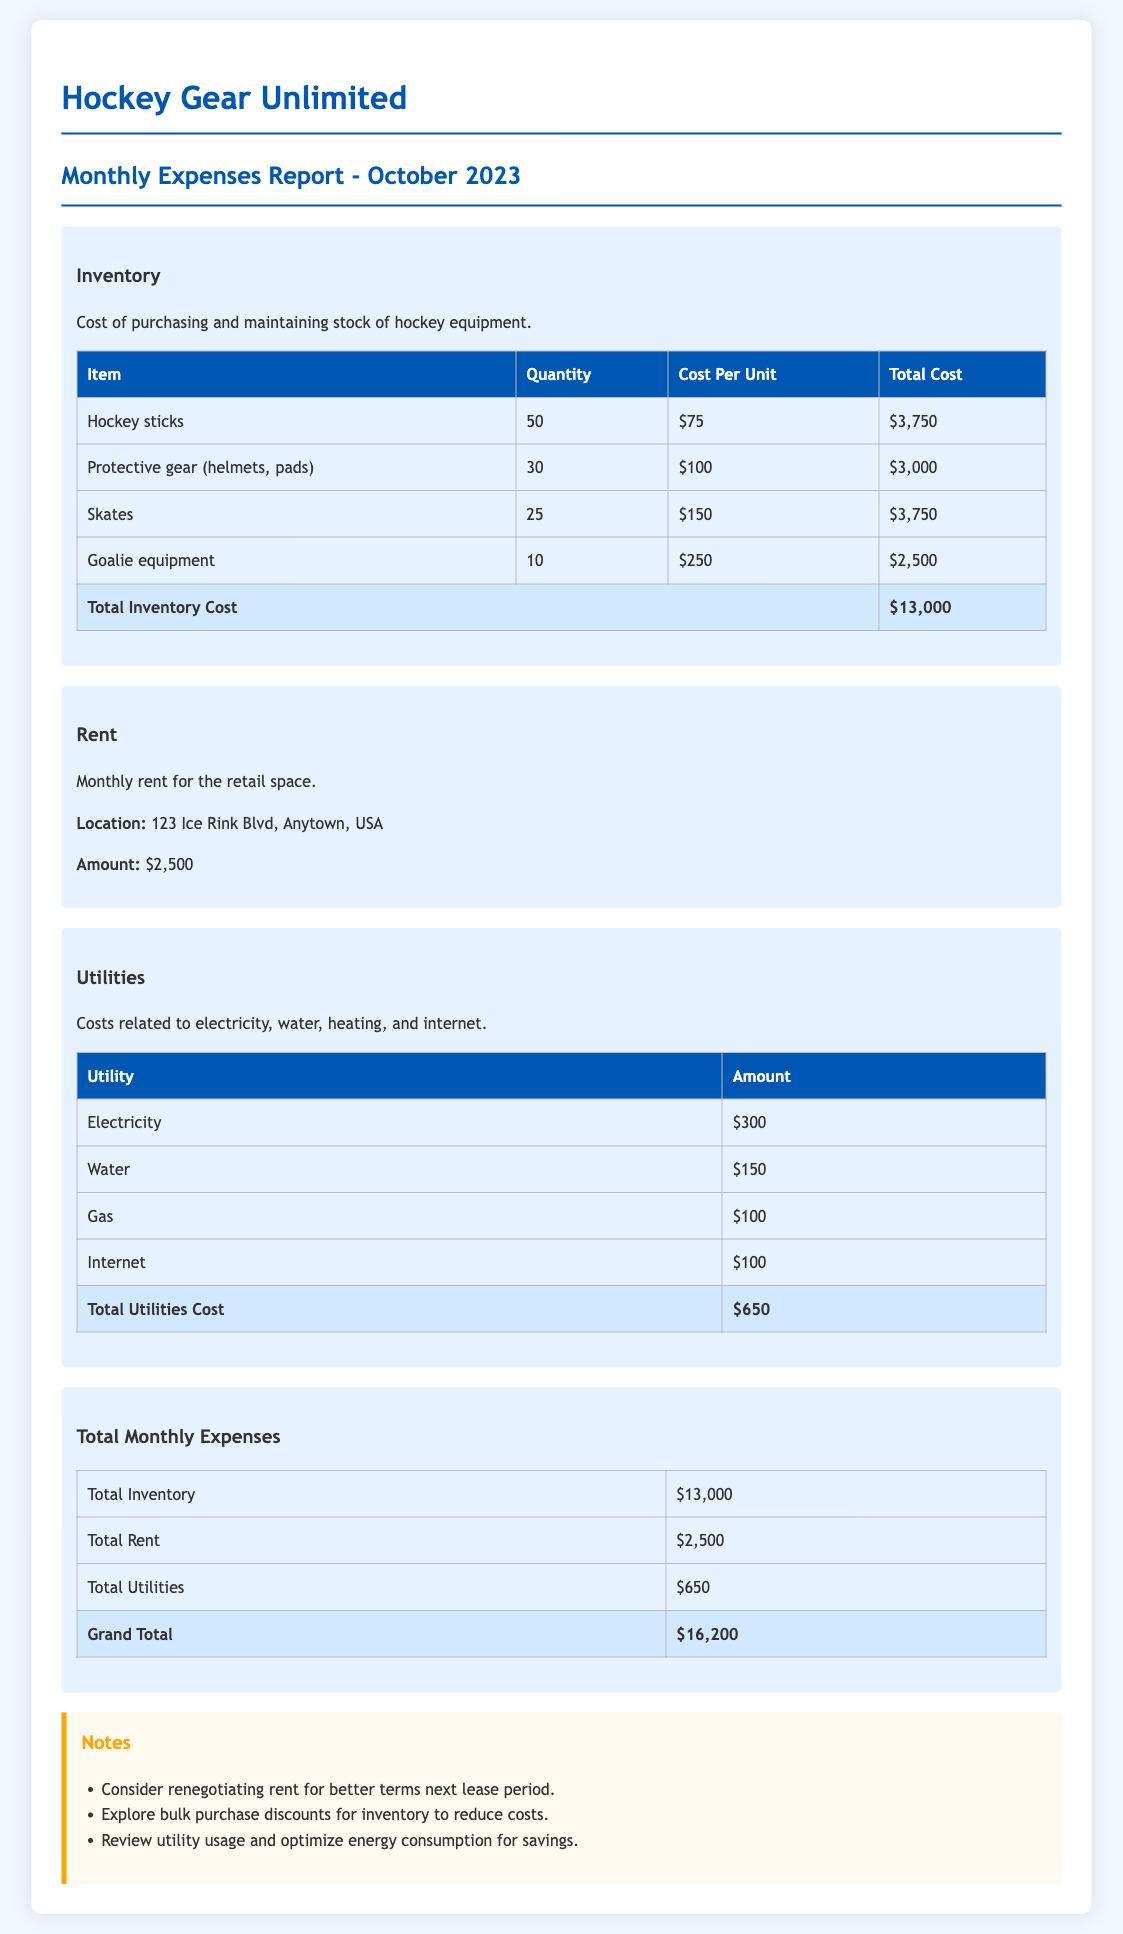What is the total cost of hockey sticks? The total cost of hockey sticks is listed in the inventory section as $3,750.
Answer: $3,750 How much is the monthly rent? The monthly rent amount for the retail space is stated directly in the rent section as $2,500.
Answer: $2,500 What is the total utilities cost? The total cost of utilities is summarized at the end of the utilities section as $650.
Answer: $650 How many pieces of protective gear were purchased? The quantity of protective gear is provided in the inventory table as 30.
Answer: 30 What is the grand total for monthly expenses? The grand total is calculated at the end of the monthly expenses section as $16,200.
Answer: $16,200 Which utility has the highest cost? The highest utility cost is electricity, listed at $300.
Answer: Electricity What recommendation is given regarding rent? The document suggests to consider renegotiating rent for better terms next lease period.
Answer: Renegotiating rent How much did the goalie equipment cost? The cost for goalie equipment is recorded in the inventory section as $2,500.
Answer: $2,500 Which utility cost is the lowest? The lowest utility cost is gas, with an amount of $100.
Answer: Gas 